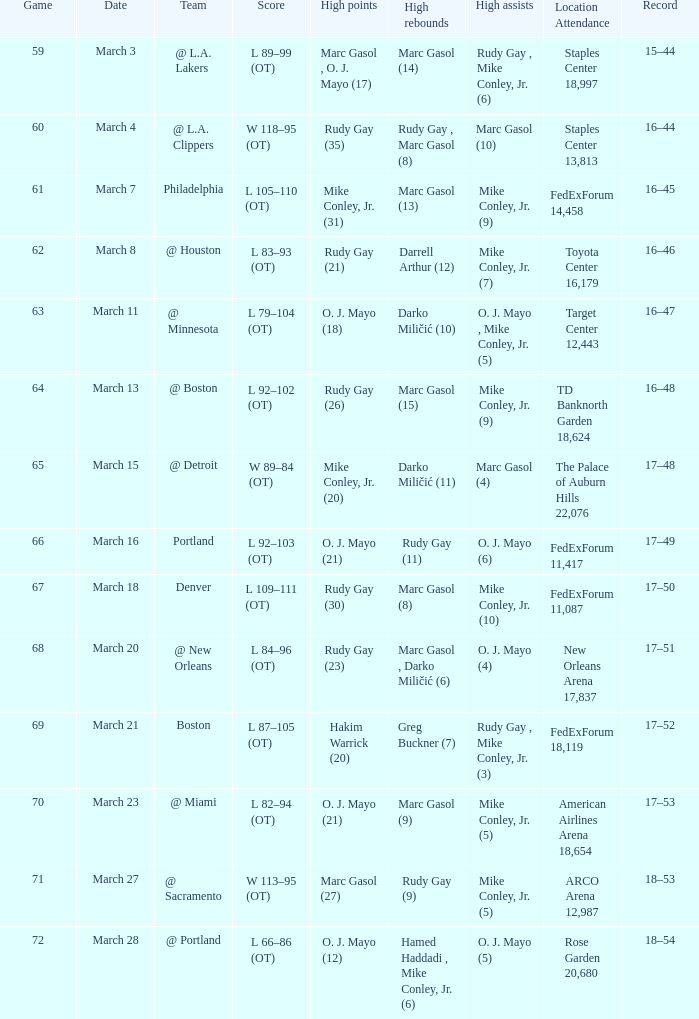Who had the highest assists on March 18? Mike Conley, Jr. (10). 